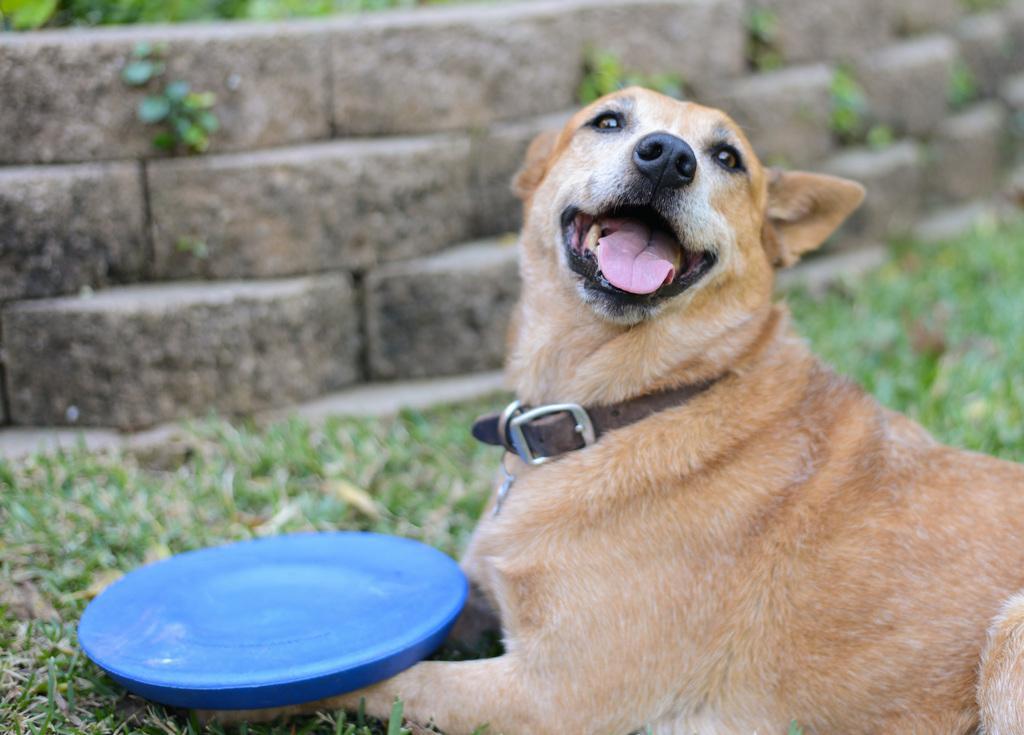How would you summarize this image in a sentence or two? There is a dog sitting on the grass,in front of this dog we can see plate. In the background we can see wall. 